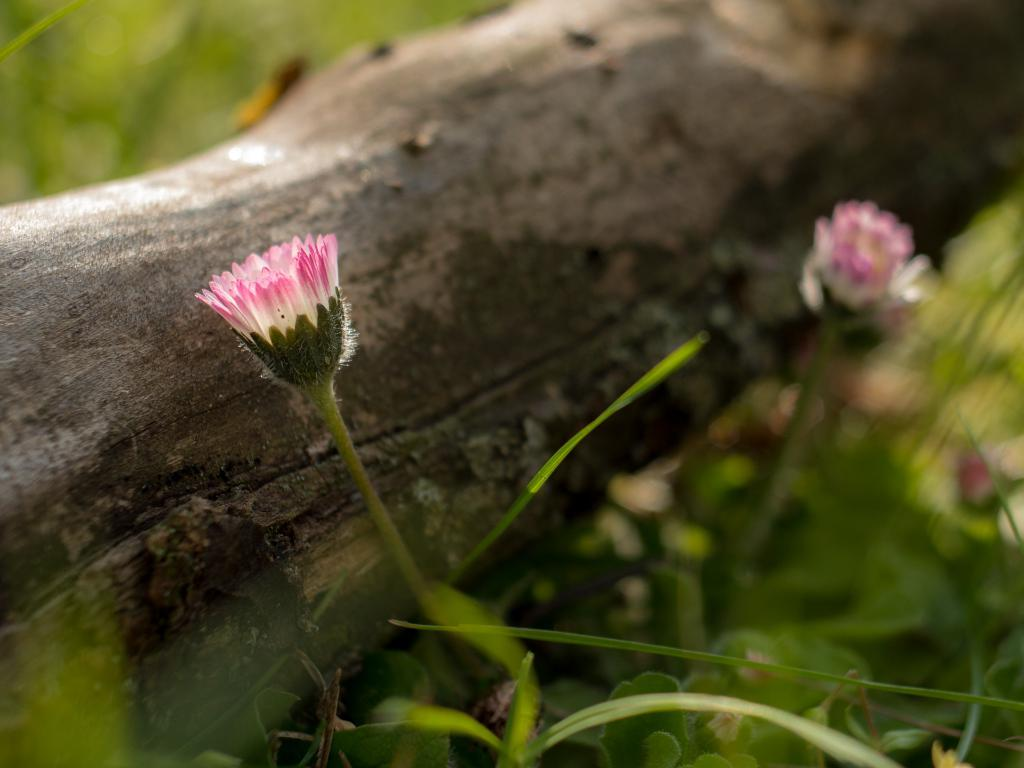What is the main subject of the image? The main subject of the image is tree bark. What other elements are present in the image besides the tree bark? There are plants with flowers in the image. What colors are the flowers? The flowers are white and purple in color. How many dogs are visible in the image? There are no dogs present in the image. What type of light source is illuminating the flowers in the image? The facts provided do not mention any light source, so it cannot be determined from the image. 